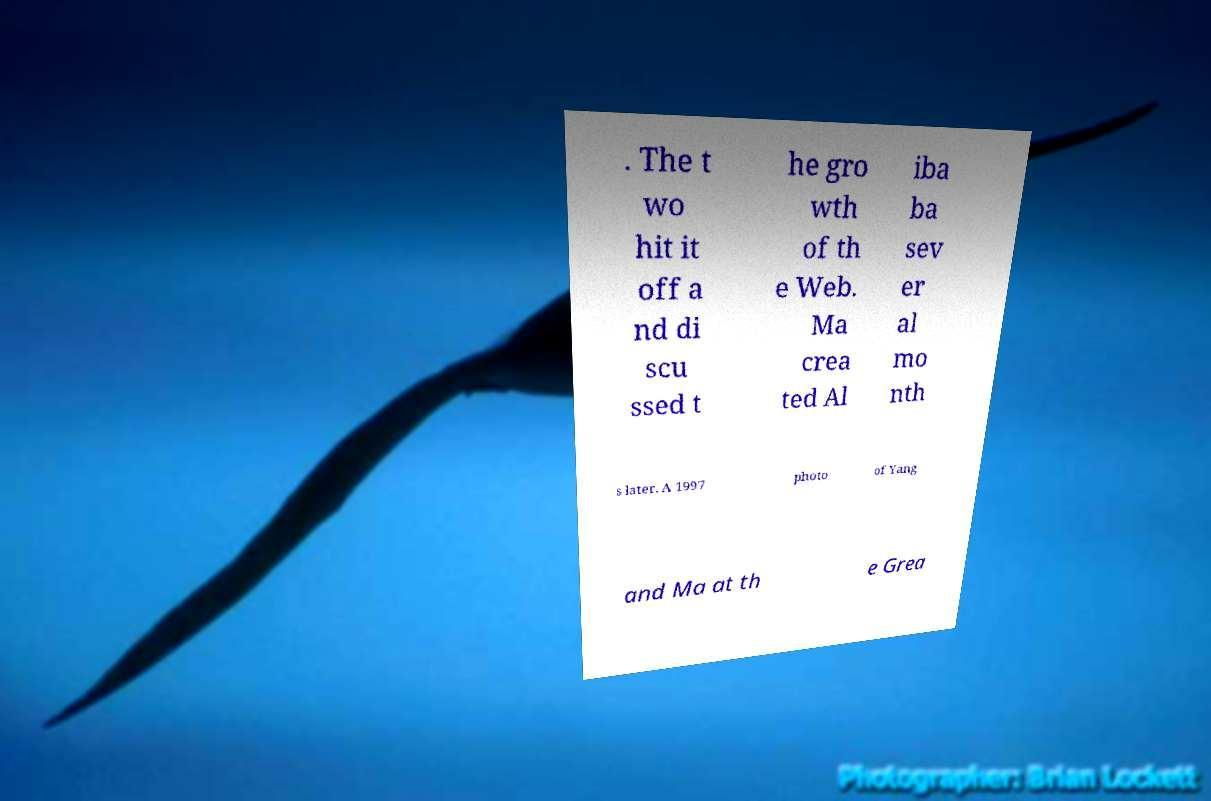Can you accurately transcribe the text from the provided image for me? . The t wo hit it off a nd di scu ssed t he gro wth of th e Web. Ma crea ted Al iba ba sev er al mo nth s later. A 1997 photo of Yang and Ma at th e Grea 